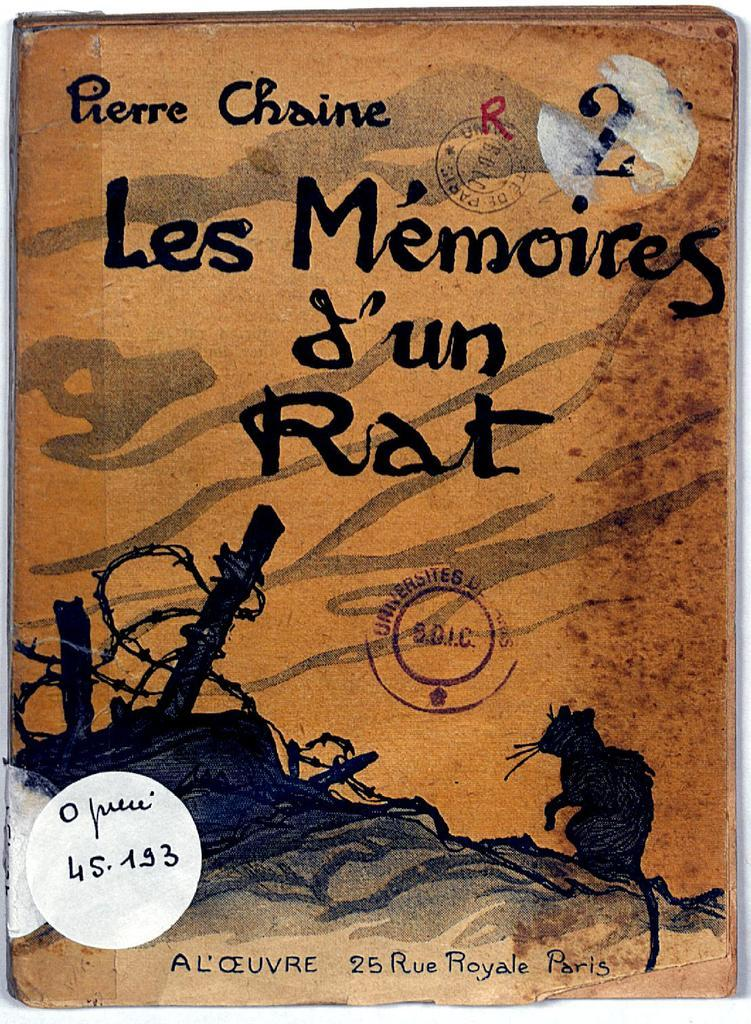<image>
Relay a brief, clear account of the picture shown. A book cover has the letter R written on it in red. 